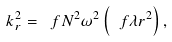<formula> <loc_0><loc_0><loc_500><loc_500>k _ { r } ^ { 2 } = \ f { N ^ { 2 } } { \omega ^ { 2 } } \left ( \ f { \lambda } { r ^ { 2 } } \right ) ,</formula> 